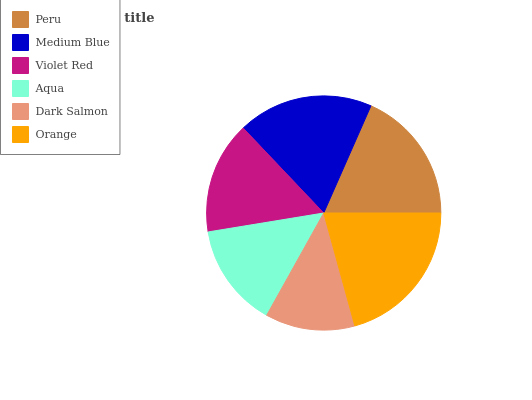Is Dark Salmon the minimum?
Answer yes or no. Yes. Is Orange the maximum?
Answer yes or no. Yes. Is Medium Blue the minimum?
Answer yes or no. No. Is Medium Blue the maximum?
Answer yes or no. No. Is Medium Blue greater than Peru?
Answer yes or no. Yes. Is Peru less than Medium Blue?
Answer yes or no. Yes. Is Peru greater than Medium Blue?
Answer yes or no. No. Is Medium Blue less than Peru?
Answer yes or no. No. Is Peru the high median?
Answer yes or no. Yes. Is Violet Red the low median?
Answer yes or no. Yes. Is Orange the high median?
Answer yes or no. No. Is Dark Salmon the low median?
Answer yes or no. No. 